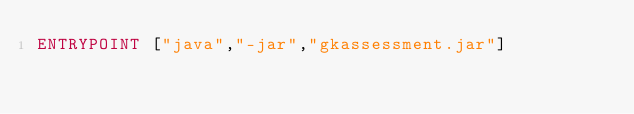<code> <loc_0><loc_0><loc_500><loc_500><_Dockerfile_>ENTRYPOINT ["java","-jar","gkassessment.jar"]
</code> 